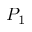Convert formula to latex. <formula><loc_0><loc_0><loc_500><loc_500>P _ { 1 }</formula> 